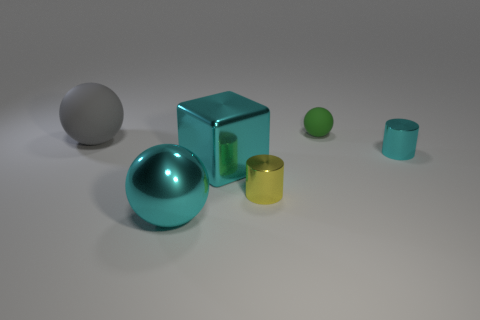Is the color of the large shiny object that is left of the block the same as the big shiny cube?
Your answer should be compact. Yes. How many other objects are there of the same size as the yellow metallic cylinder?
Your answer should be very brief. 2. What number of tiny gray metal balls are there?
Keep it short and to the point. 0. Are the cyan thing that is right of the cyan shiny cube and the big cyan object that is in front of the tiny yellow cylinder made of the same material?
Offer a very short reply. Yes. What material is the tiny green ball?
Offer a very short reply. Rubber. What number of tiny objects are the same material as the cube?
Give a very brief answer. 2. How many metallic objects are either cyan cubes or small green balls?
Provide a succinct answer. 1. There is a tiny metallic thing that is right of the green thing; does it have the same shape as the tiny yellow object to the right of the big gray object?
Offer a very short reply. Yes. There is a thing that is both in front of the large cyan cube and on the right side of the large cyan metallic ball; what is its color?
Make the answer very short. Yellow. Do the gray object that is left of the cyan block and the rubber object that is on the right side of the gray object have the same size?
Your response must be concise. No. 